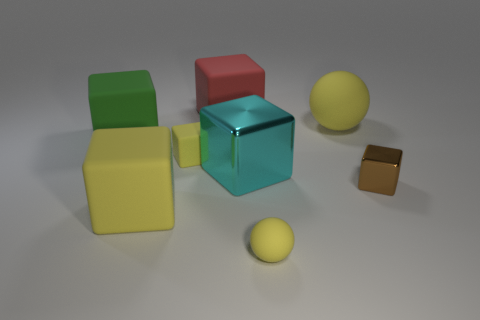Does the small rubber cube have the same color as the tiny ball?
Offer a terse response. Yes. The other sphere that is the same color as the big ball is what size?
Provide a succinct answer. Small. There is a tiny sphere; is it the same color as the sphere behind the green matte block?
Provide a short and direct response. Yes. Is the color of the matte ball that is behind the small brown block the same as the small ball?
Offer a terse response. Yes. Is there anything else of the same color as the small rubber ball?
Provide a short and direct response. Yes. There is a big thing that is the same color as the big ball; what is its shape?
Provide a succinct answer. Cube. Are there the same number of green matte cubes that are to the right of the big yellow sphere and things that are left of the small yellow matte cube?
Provide a short and direct response. No. What number of other objects are there of the same material as the big cyan block?
Your response must be concise. 1. Is the number of blocks left of the tiny brown shiny cube the same as the number of large green objects?
Offer a very short reply. No. Do the brown metallic object and the yellow matte block behind the big cyan thing have the same size?
Your response must be concise. Yes. 